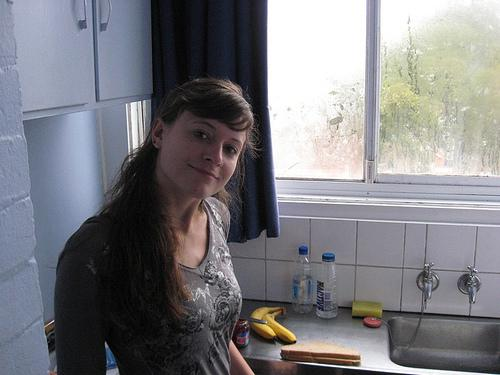Question: how many taps are on the sink?
Choices:
A. Three.
B. Two.
C. Eight.
D. Seven.
Answer with the letter. Answer: B Question: what is the woman doing?
Choices:
A. Singing.
B. Talking.
C. Smiling.
D. Screaming.
Answer with the letter. Answer: C Question: what food is on the counter?
Choices:
A. Cake.
B. Bananas and bread.
C. Pie.
D. Cookies.
Answer with the letter. Answer: B Question: why is he window blurry?
Choices:
A. It's fogged up.
B. The wind is blowing hard.
C. It's raining outside.
D. It's steamed up.
Answer with the letter. Answer: C Question: where is she standing?
Choices:
A. By the door.
B. At the bus stop.
C. Near a pool.
D. Near the counter.
Answer with the letter. Answer: D Question: what color is her hair?
Choices:
A. Blonde.
B. Brown.
C. Black.
D. Grey.
Answer with the letter. Answer: B Question: who is near the wall?
Choices:
A. A boy.
B. A girl.
C. The woman.
D. A man.
Answer with the letter. Answer: C 